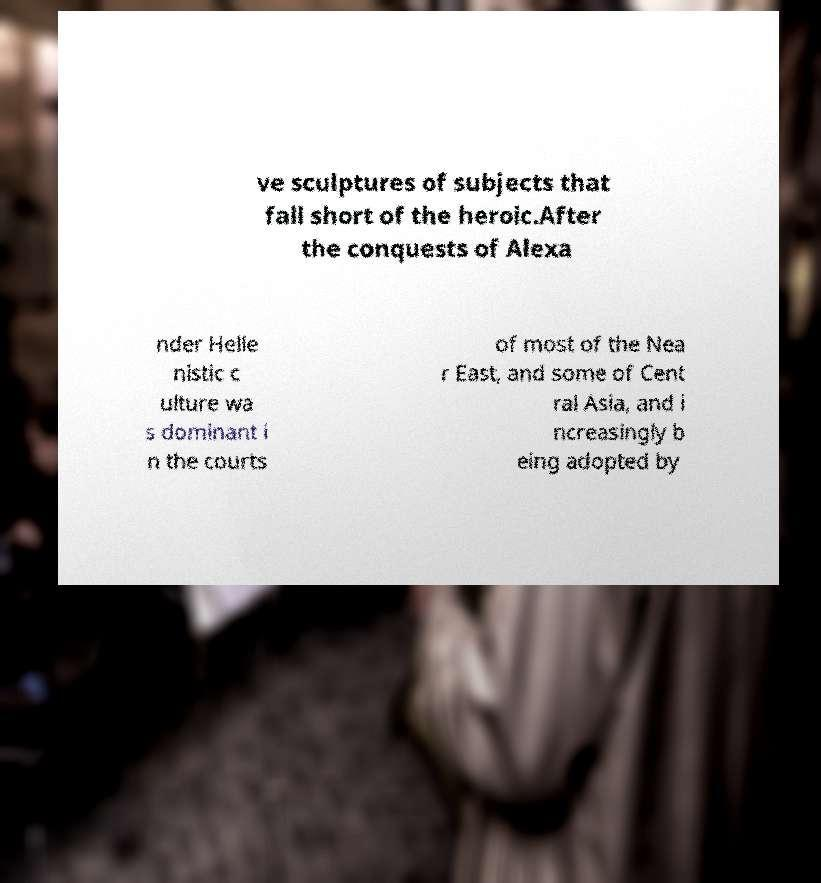I need the written content from this picture converted into text. Can you do that? ve sculptures of subjects that fall short of the heroic.After the conquests of Alexa nder Helle nistic c ulture wa s dominant i n the courts of most of the Nea r East, and some of Cent ral Asia, and i ncreasingly b eing adopted by 